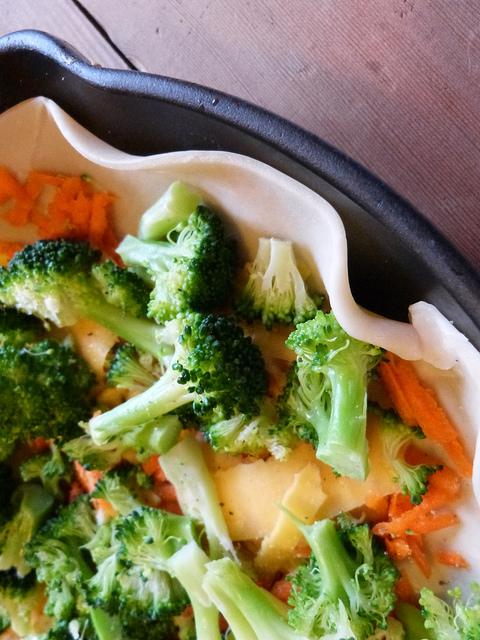Could this cuisine be Asian?
Answer briefly. Yes. Has the dish been cooked yet?
Keep it brief. No. What is the green vegetable?
Be succinct. Broccoli. 